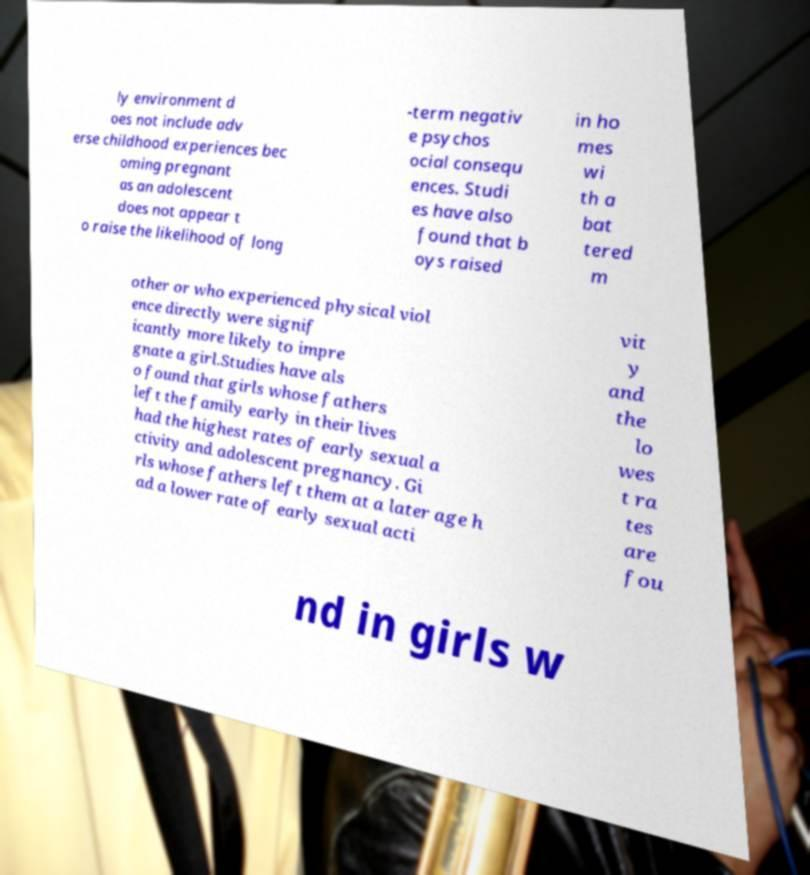I need the written content from this picture converted into text. Can you do that? ly environment d oes not include adv erse childhood experiences bec oming pregnant as an adolescent does not appear t o raise the likelihood of long -term negativ e psychos ocial consequ ences. Studi es have also found that b oys raised in ho mes wi th a bat tered m other or who experienced physical viol ence directly were signif icantly more likely to impre gnate a girl.Studies have als o found that girls whose fathers left the family early in their lives had the highest rates of early sexual a ctivity and adolescent pregnancy. Gi rls whose fathers left them at a later age h ad a lower rate of early sexual acti vit y and the lo wes t ra tes are fou nd in girls w 